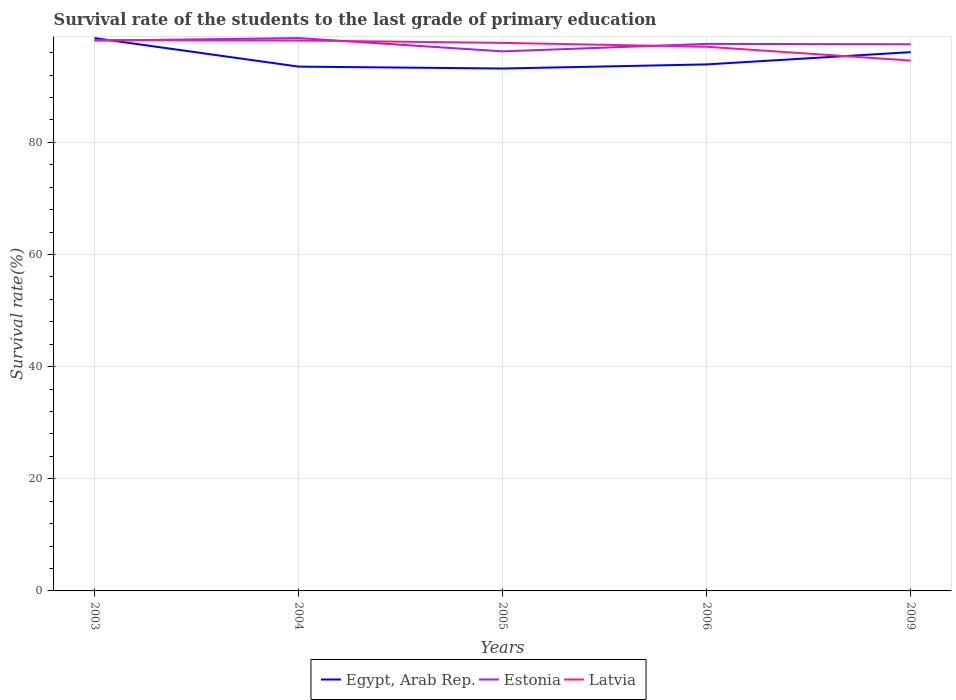Does the line corresponding to Latvia intersect with the line corresponding to Estonia?
Offer a terse response. Yes. Is the number of lines equal to the number of legend labels?
Offer a terse response. Yes. Across all years, what is the maximum survival rate of the students in Latvia?
Ensure brevity in your answer.  94.6. In which year was the survival rate of the students in Latvia maximum?
Your answer should be very brief. 2009. What is the total survival rate of the students in Egypt, Arab Rep. in the graph?
Give a very brief answer. 0.34. What is the difference between the highest and the second highest survival rate of the students in Egypt, Arab Rep.?
Keep it short and to the point. 5.42. How many lines are there?
Your response must be concise. 3. How many years are there in the graph?
Offer a terse response. 5. What is the difference between two consecutive major ticks on the Y-axis?
Provide a succinct answer. 20. Are the values on the major ticks of Y-axis written in scientific E-notation?
Keep it short and to the point. No. Where does the legend appear in the graph?
Offer a very short reply. Bottom center. How are the legend labels stacked?
Give a very brief answer. Horizontal. What is the title of the graph?
Keep it short and to the point. Survival rate of the students to the last grade of primary education. What is the label or title of the Y-axis?
Your answer should be compact. Survival rate(%). What is the Survival rate(%) in Egypt, Arab Rep. in 2003?
Make the answer very short. 98.6. What is the Survival rate(%) in Estonia in 2003?
Provide a short and direct response. 98.15. What is the Survival rate(%) of Latvia in 2003?
Your response must be concise. 98.25. What is the Survival rate(%) in Egypt, Arab Rep. in 2004?
Provide a succinct answer. 93.52. What is the Survival rate(%) of Estonia in 2004?
Keep it short and to the point. 98.6. What is the Survival rate(%) in Latvia in 2004?
Keep it short and to the point. 98.17. What is the Survival rate(%) in Egypt, Arab Rep. in 2005?
Ensure brevity in your answer.  93.18. What is the Survival rate(%) in Estonia in 2005?
Your answer should be very brief. 96.24. What is the Survival rate(%) of Latvia in 2005?
Your answer should be compact. 97.75. What is the Survival rate(%) in Egypt, Arab Rep. in 2006?
Keep it short and to the point. 93.91. What is the Survival rate(%) of Estonia in 2006?
Your answer should be compact. 97.57. What is the Survival rate(%) in Latvia in 2006?
Give a very brief answer. 97.06. What is the Survival rate(%) of Egypt, Arab Rep. in 2009?
Ensure brevity in your answer.  96.1. What is the Survival rate(%) in Estonia in 2009?
Make the answer very short. 97.5. What is the Survival rate(%) in Latvia in 2009?
Your answer should be compact. 94.6. Across all years, what is the maximum Survival rate(%) in Egypt, Arab Rep.?
Keep it short and to the point. 98.6. Across all years, what is the maximum Survival rate(%) in Estonia?
Offer a very short reply. 98.6. Across all years, what is the maximum Survival rate(%) of Latvia?
Ensure brevity in your answer.  98.25. Across all years, what is the minimum Survival rate(%) of Egypt, Arab Rep.?
Offer a very short reply. 93.18. Across all years, what is the minimum Survival rate(%) in Estonia?
Your answer should be very brief. 96.24. Across all years, what is the minimum Survival rate(%) in Latvia?
Your answer should be very brief. 94.6. What is the total Survival rate(%) of Egypt, Arab Rep. in the graph?
Give a very brief answer. 475.31. What is the total Survival rate(%) in Estonia in the graph?
Your answer should be compact. 488.06. What is the total Survival rate(%) in Latvia in the graph?
Keep it short and to the point. 485.83. What is the difference between the Survival rate(%) of Egypt, Arab Rep. in 2003 and that in 2004?
Make the answer very short. 5.08. What is the difference between the Survival rate(%) of Estonia in 2003 and that in 2004?
Provide a short and direct response. -0.45. What is the difference between the Survival rate(%) in Latvia in 2003 and that in 2004?
Your answer should be very brief. 0.08. What is the difference between the Survival rate(%) of Egypt, Arab Rep. in 2003 and that in 2005?
Provide a succinct answer. 5.42. What is the difference between the Survival rate(%) of Estonia in 2003 and that in 2005?
Provide a succinct answer. 1.91. What is the difference between the Survival rate(%) in Latvia in 2003 and that in 2005?
Your answer should be compact. 0.49. What is the difference between the Survival rate(%) in Egypt, Arab Rep. in 2003 and that in 2006?
Provide a succinct answer. 4.69. What is the difference between the Survival rate(%) in Estonia in 2003 and that in 2006?
Your answer should be very brief. 0.58. What is the difference between the Survival rate(%) in Latvia in 2003 and that in 2006?
Keep it short and to the point. 1.19. What is the difference between the Survival rate(%) in Egypt, Arab Rep. in 2003 and that in 2009?
Ensure brevity in your answer.  2.5. What is the difference between the Survival rate(%) in Estonia in 2003 and that in 2009?
Offer a very short reply. 0.65. What is the difference between the Survival rate(%) in Latvia in 2003 and that in 2009?
Offer a terse response. 3.65. What is the difference between the Survival rate(%) of Egypt, Arab Rep. in 2004 and that in 2005?
Make the answer very short. 0.34. What is the difference between the Survival rate(%) of Estonia in 2004 and that in 2005?
Give a very brief answer. 2.37. What is the difference between the Survival rate(%) of Latvia in 2004 and that in 2005?
Ensure brevity in your answer.  0.42. What is the difference between the Survival rate(%) in Egypt, Arab Rep. in 2004 and that in 2006?
Your answer should be very brief. -0.39. What is the difference between the Survival rate(%) in Estonia in 2004 and that in 2006?
Offer a very short reply. 1.03. What is the difference between the Survival rate(%) of Latvia in 2004 and that in 2006?
Provide a short and direct response. 1.11. What is the difference between the Survival rate(%) in Egypt, Arab Rep. in 2004 and that in 2009?
Provide a succinct answer. -2.58. What is the difference between the Survival rate(%) of Estonia in 2004 and that in 2009?
Your answer should be very brief. 1.1. What is the difference between the Survival rate(%) of Latvia in 2004 and that in 2009?
Provide a short and direct response. 3.57. What is the difference between the Survival rate(%) of Egypt, Arab Rep. in 2005 and that in 2006?
Offer a terse response. -0.73. What is the difference between the Survival rate(%) of Estonia in 2005 and that in 2006?
Ensure brevity in your answer.  -1.33. What is the difference between the Survival rate(%) of Latvia in 2005 and that in 2006?
Offer a very short reply. 0.69. What is the difference between the Survival rate(%) in Egypt, Arab Rep. in 2005 and that in 2009?
Make the answer very short. -2.92. What is the difference between the Survival rate(%) of Estonia in 2005 and that in 2009?
Provide a succinct answer. -1.26. What is the difference between the Survival rate(%) of Latvia in 2005 and that in 2009?
Your answer should be compact. 3.15. What is the difference between the Survival rate(%) of Egypt, Arab Rep. in 2006 and that in 2009?
Keep it short and to the point. -2.19. What is the difference between the Survival rate(%) of Estonia in 2006 and that in 2009?
Make the answer very short. 0.07. What is the difference between the Survival rate(%) of Latvia in 2006 and that in 2009?
Offer a terse response. 2.46. What is the difference between the Survival rate(%) in Egypt, Arab Rep. in 2003 and the Survival rate(%) in Estonia in 2004?
Ensure brevity in your answer.  -0. What is the difference between the Survival rate(%) in Egypt, Arab Rep. in 2003 and the Survival rate(%) in Latvia in 2004?
Your answer should be very brief. 0.43. What is the difference between the Survival rate(%) of Estonia in 2003 and the Survival rate(%) of Latvia in 2004?
Keep it short and to the point. -0.02. What is the difference between the Survival rate(%) of Egypt, Arab Rep. in 2003 and the Survival rate(%) of Estonia in 2005?
Provide a short and direct response. 2.37. What is the difference between the Survival rate(%) in Egypt, Arab Rep. in 2003 and the Survival rate(%) in Latvia in 2005?
Give a very brief answer. 0.85. What is the difference between the Survival rate(%) of Estonia in 2003 and the Survival rate(%) of Latvia in 2005?
Offer a very short reply. 0.4. What is the difference between the Survival rate(%) of Egypt, Arab Rep. in 2003 and the Survival rate(%) of Estonia in 2006?
Ensure brevity in your answer.  1.03. What is the difference between the Survival rate(%) in Egypt, Arab Rep. in 2003 and the Survival rate(%) in Latvia in 2006?
Ensure brevity in your answer.  1.54. What is the difference between the Survival rate(%) in Estonia in 2003 and the Survival rate(%) in Latvia in 2006?
Ensure brevity in your answer.  1.09. What is the difference between the Survival rate(%) in Egypt, Arab Rep. in 2003 and the Survival rate(%) in Estonia in 2009?
Provide a succinct answer. 1.1. What is the difference between the Survival rate(%) of Egypt, Arab Rep. in 2003 and the Survival rate(%) of Latvia in 2009?
Ensure brevity in your answer.  4. What is the difference between the Survival rate(%) of Estonia in 2003 and the Survival rate(%) of Latvia in 2009?
Your answer should be compact. 3.55. What is the difference between the Survival rate(%) in Egypt, Arab Rep. in 2004 and the Survival rate(%) in Estonia in 2005?
Keep it short and to the point. -2.72. What is the difference between the Survival rate(%) in Egypt, Arab Rep. in 2004 and the Survival rate(%) in Latvia in 2005?
Provide a short and direct response. -4.23. What is the difference between the Survival rate(%) of Estonia in 2004 and the Survival rate(%) of Latvia in 2005?
Provide a succinct answer. 0.85. What is the difference between the Survival rate(%) of Egypt, Arab Rep. in 2004 and the Survival rate(%) of Estonia in 2006?
Offer a terse response. -4.05. What is the difference between the Survival rate(%) of Egypt, Arab Rep. in 2004 and the Survival rate(%) of Latvia in 2006?
Your response must be concise. -3.54. What is the difference between the Survival rate(%) in Estonia in 2004 and the Survival rate(%) in Latvia in 2006?
Make the answer very short. 1.54. What is the difference between the Survival rate(%) of Egypt, Arab Rep. in 2004 and the Survival rate(%) of Estonia in 2009?
Keep it short and to the point. -3.98. What is the difference between the Survival rate(%) in Egypt, Arab Rep. in 2004 and the Survival rate(%) in Latvia in 2009?
Provide a short and direct response. -1.08. What is the difference between the Survival rate(%) of Estonia in 2004 and the Survival rate(%) of Latvia in 2009?
Your answer should be compact. 4. What is the difference between the Survival rate(%) in Egypt, Arab Rep. in 2005 and the Survival rate(%) in Estonia in 2006?
Provide a short and direct response. -4.39. What is the difference between the Survival rate(%) of Egypt, Arab Rep. in 2005 and the Survival rate(%) of Latvia in 2006?
Provide a succinct answer. -3.88. What is the difference between the Survival rate(%) of Estonia in 2005 and the Survival rate(%) of Latvia in 2006?
Your response must be concise. -0.82. What is the difference between the Survival rate(%) of Egypt, Arab Rep. in 2005 and the Survival rate(%) of Estonia in 2009?
Offer a very short reply. -4.32. What is the difference between the Survival rate(%) in Egypt, Arab Rep. in 2005 and the Survival rate(%) in Latvia in 2009?
Your response must be concise. -1.42. What is the difference between the Survival rate(%) in Estonia in 2005 and the Survival rate(%) in Latvia in 2009?
Make the answer very short. 1.64. What is the difference between the Survival rate(%) in Egypt, Arab Rep. in 2006 and the Survival rate(%) in Estonia in 2009?
Offer a very short reply. -3.59. What is the difference between the Survival rate(%) in Egypt, Arab Rep. in 2006 and the Survival rate(%) in Latvia in 2009?
Make the answer very short. -0.69. What is the difference between the Survival rate(%) of Estonia in 2006 and the Survival rate(%) of Latvia in 2009?
Offer a terse response. 2.97. What is the average Survival rate(%) in Egypt, Arab Rep. per year?
Your answer should be very brief. 95.06. What is the average Survival rate(%) in Estonia per year?
Keep it short and to the point. 97.61. What is the average Survival rate(%) of Latvia per year?
Give a very brief answer. 97.17. In the year 2003, what is the difference between the Survival rate(%) of Egypt, Arab Rep. and Survival rate(%) of Estonia?
Provide a succinct answer. 0.45. In the year 2003, what is the difference between the Survival rate(%) in Egypt, Arab Rep. and Survival rate(%) in Latvia?
Your answer should be compact. 0.36. In the year 2003, what is the difference between the Survival rate(%) in Estonia and Survival rate(%) in Latvia?
Ensure brevity in your answer.  -0.1. In the year 2004, what is the difference between the Survival rate(%) in Egypt, Arab Rep. and Survival rate(%) in Estonia?
Your response must be concise. -5.08. In the year 2004, what is the difference between the Survival rate(%) in Egypt, Arab Rep. and Survival rate(%) in Latvia?
Provide a short and direct response. -4.65. In the year 2004, what is the difference between the Survival rate(%) of Estonia and Survival rate(%) of Latvia?
Offer a terse response. 0.43. In the year 2005, what is the difference between the Survival rate(%) of Egypt, Arab Rep. and Survival rate(%) of Estonia?
Keep it short and to the point. -3.06. In the year 2005, what is the difference between the Survival rate(%) in Egypt, Arab Rep. and Survival rate(%) in Latvia?
Your response must be concise. -4.57. In the year 2005, what is the difference between the Survival rate(%) of Estonia and Survival rate(%) of Latvia?
Offer a terse response. -1.52. In the year 2006, what is the difference between the Survival rate(%) in Egypt, Arab Rep. and Survival rate(%) in Estonia?
Keep it short and to the point. -3.66. In the year 2006, what is the difference between the Survival rate(%) of Egypt, Arab Rep. and Survival rate(%) of Latvia?
Make the answer very short. -3.15. In the year 2006, what is the difference between the Survival rate(%) of Estonia and Survival rate(%) of Latvia?
Keep it short and to the point. 0.51. In the year 2009, what is the difference between the Survival rate(%) in Egypt, Arab Rep. and Survival rate(%) in Estonia?
Your answer should be compact. -1.4. In the year 2009, what is the difference between the Survival rate(%) in Egypt, Arab Rep. and Survival rate(%) in Latvia?
Offer a very short reply. 1.5. In the year 2009, what is the difference between the Survival rate(%) in Estonia and Survival rate(%) in Latvia?
Offer a very short reply. 2.9. What is the ratio of the Survival rate(%) of Egypt, Arab Rep. in 2003 to that in 2004?
Offer a terse response. 1.05. What is the ratio of the Survival rate(%) in Estonia in 2003 to that in 2004?
Your answer should be very brief. 1. What is the ratio of the Survival rate(%) of Latvia in 2003 to that in 2004?
Ensure brevity in your answer.  1. What is the ratio of the Survival rate(%) in Egypt, Arab Rep. in 2003 to that in 2005?
Offer a very short reply. 1.06. What is the ratio of the Survival rate(%) in Estonia in 2003 to that in 2005?
Your response must be concise. 1.02. What is the ratio of the Survival rate(%) of Latvia in 2003 to that in 2005?
Offer a very short reply. 1.01. What is the ratio of the Survival rate(%) of Egypt, Arab Rep. in 2003 to that in 2006?
Offer a terse response. 1.05. What is the ratio of the Survival rate(%) of Latvia in 2003 to that in 2006?
Keep it short and to the point. 1.01. What is the ratio of the Survival rate(%) in Egypt, Arab Rep. in 2003 to that in 2009?
Offer a very short reply. 1.03. What is the ratio of the Survival rate(%) in Estonia in 2003 to that in 2009?
Offer a terse response. 1.01. What is the ratio of the Survival rate(%) of Egypt, Arab Rep. in 2004 to that in 2005?
Offer a terse response. 1. What is the ratio of the Survival rate(%) in Estonia in 2004 to that in 2005?
Provide a succinct answer. 1.02. What is the ratio of the Survival rate(%) in Estonia in 2004 to that in 2006?
Make the answer very short. 1.01. What is the ratio of the Survival rate(%) in Latvia in 2004 to that in 2006?
Your answer should be compact. 1.01. What is the ratio of the Survival rate(%) of Egypt, Arab Rep. in 2004 to that in 2009?
Provide a succinct answer. 0.97. What is the ratio of the Survival rate(%) of Estonia in 2004 to that in 2009?
Provide a succinct answer. 1.01. What is the ratio of the Survival rate(%) in Latvia in 2004 to that in 2009?
Make the answer very short. 1.04. What is the ratio of the Survival rate(%) in Egypt, Arab Rep. in 2005 to that in 2006?
Provide a succinct answer. 0.99. What is the ratio of the Survival rate(%) in Estonia in 2005 to that in 2006?
Ensure brevity in your answer.  0.99. What is the ratio of the Survival rate(%) in Latvia in 2005 to that in 2006?
Provide a succinct answer. 1.01. What is the ratio of the Survival rate(%) of Egypt, Arab Rep. in 2005 to that in 2009?
Your response must be concise. 0.97. What is the ratio of the Survival rate(%) of Estonia in 2005 to that in 2009?
Offer a very short reply. 0.99. What is the ratio of the Survival rate(%) in Latvia in 2005 to that in 2009?
Your response must be concise. 1.03. What is the ratio of the Survival rate(%) in Egypt, Arab Rep. in 2006 to that in 2009?
Your answer should be very brief. 0.98. What is the difference between the highest and the second highest Survival rate(%) in Egypt, Arab Rep.?
Ensure brevity in your answer.  2.5. What is the difference between the highest and the second highest Survival rate(%) in Estonia?
Keep it short and to the point. 0.45. What is the difference between the highest and the second highest Survival rate(%) in Latvia?
Your answer should be compact. 0.08. What is the difference between the highest and the lowest Survival rate(%) of Egypt, Arab Rep.?
Provide a succinct answer. 5.42. What is the difference between the highest and the lowest Survival rate(%) of Estonia?
Offer a terse response. 2.37. What is the difference between the highest and the lowest Survival rate(%) of Latvia?
Provide a succinct answer. 3.65. 